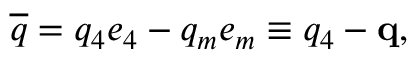Convert formula to latex. <formula><loc_0><loc_0><loc_500><loc_500>\overline { q } = q _ { 4 } e _ { 4 } - q _ { m } e _ { m } \equiv q _ { 4 } - q ,</formula> 